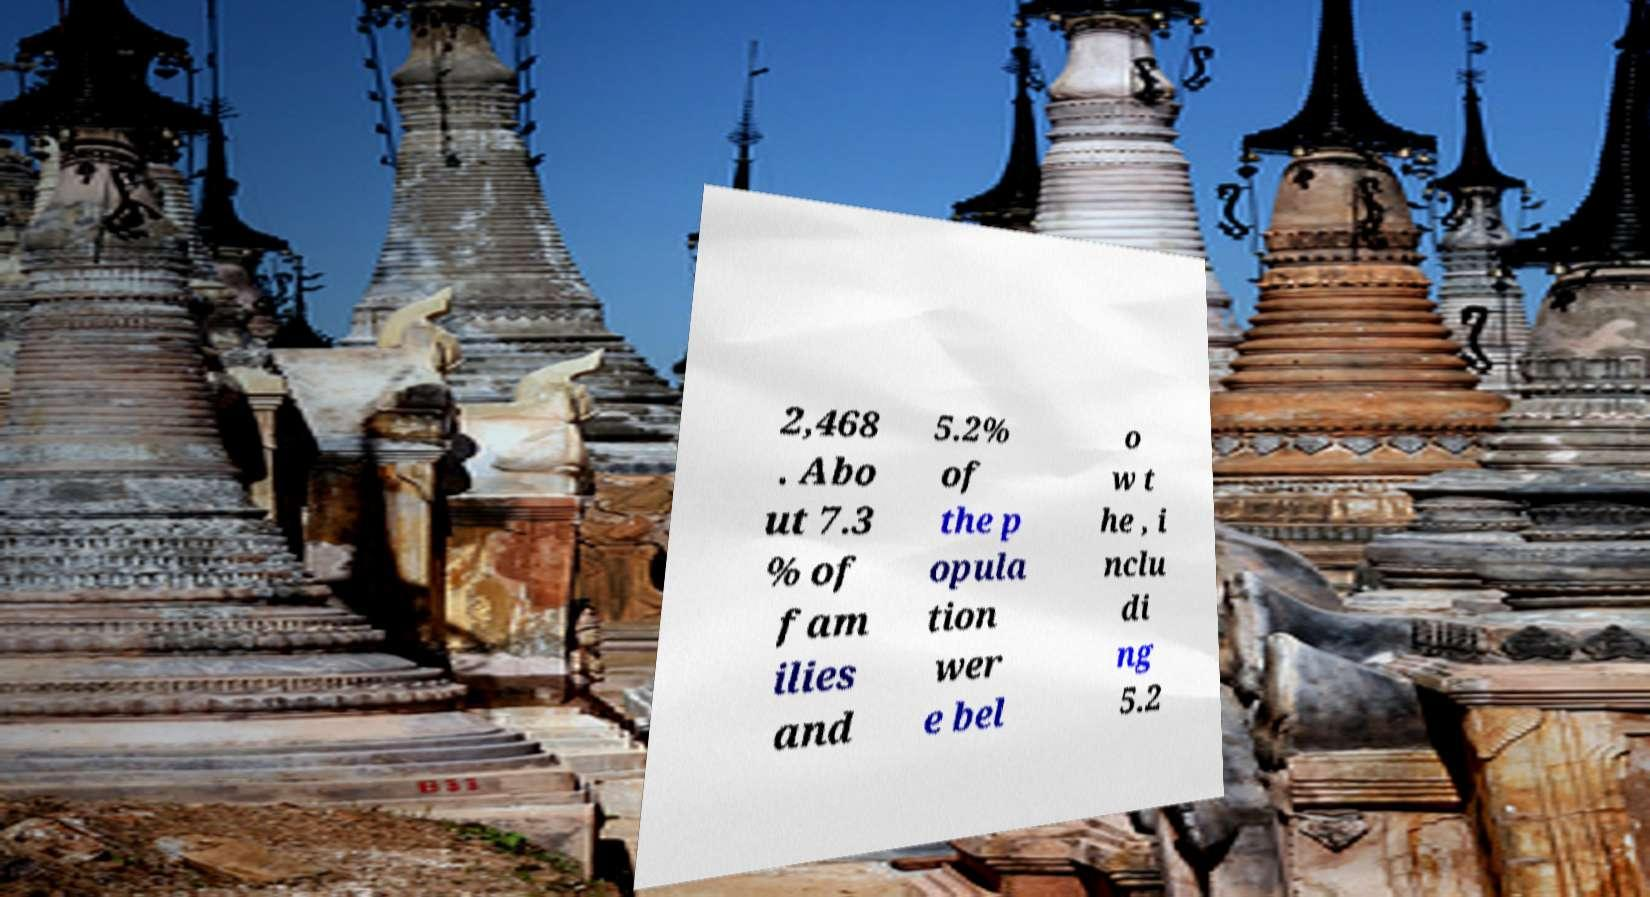I need the written content from this picture converted into text. Can you do that? 2,468 . Abo ut 7.3 % of fam ilies and 5.2% of the p opula tion wer e bel o w t he , i nclu di ng 5.2 